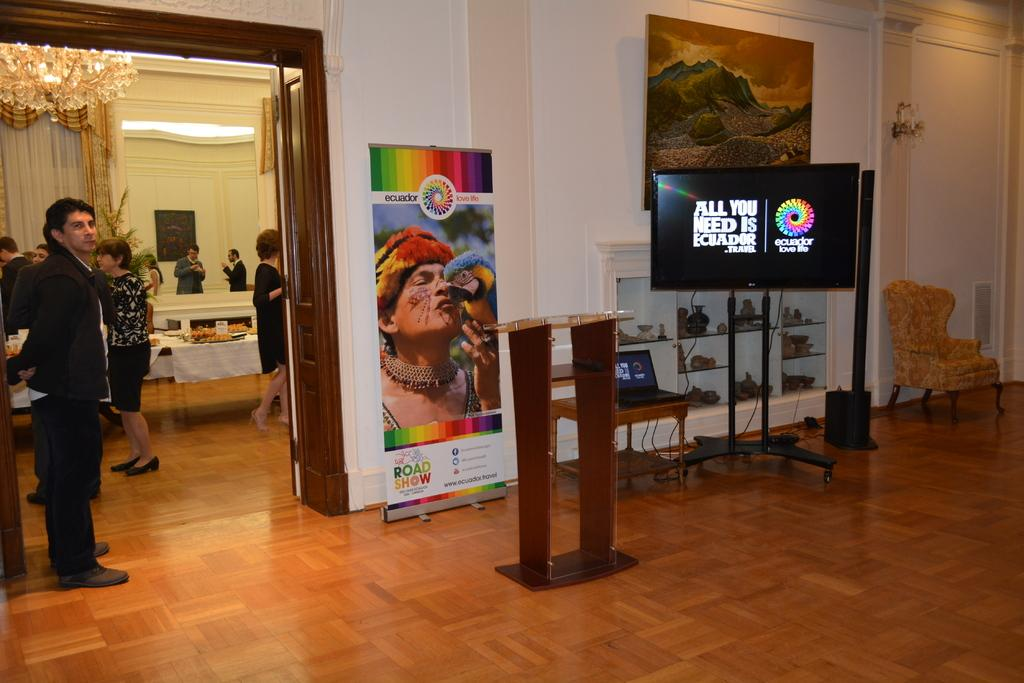<image>
Present a compact description of the photo's key features. Posters and a video display tout the merits of traveling to Ecuador. 